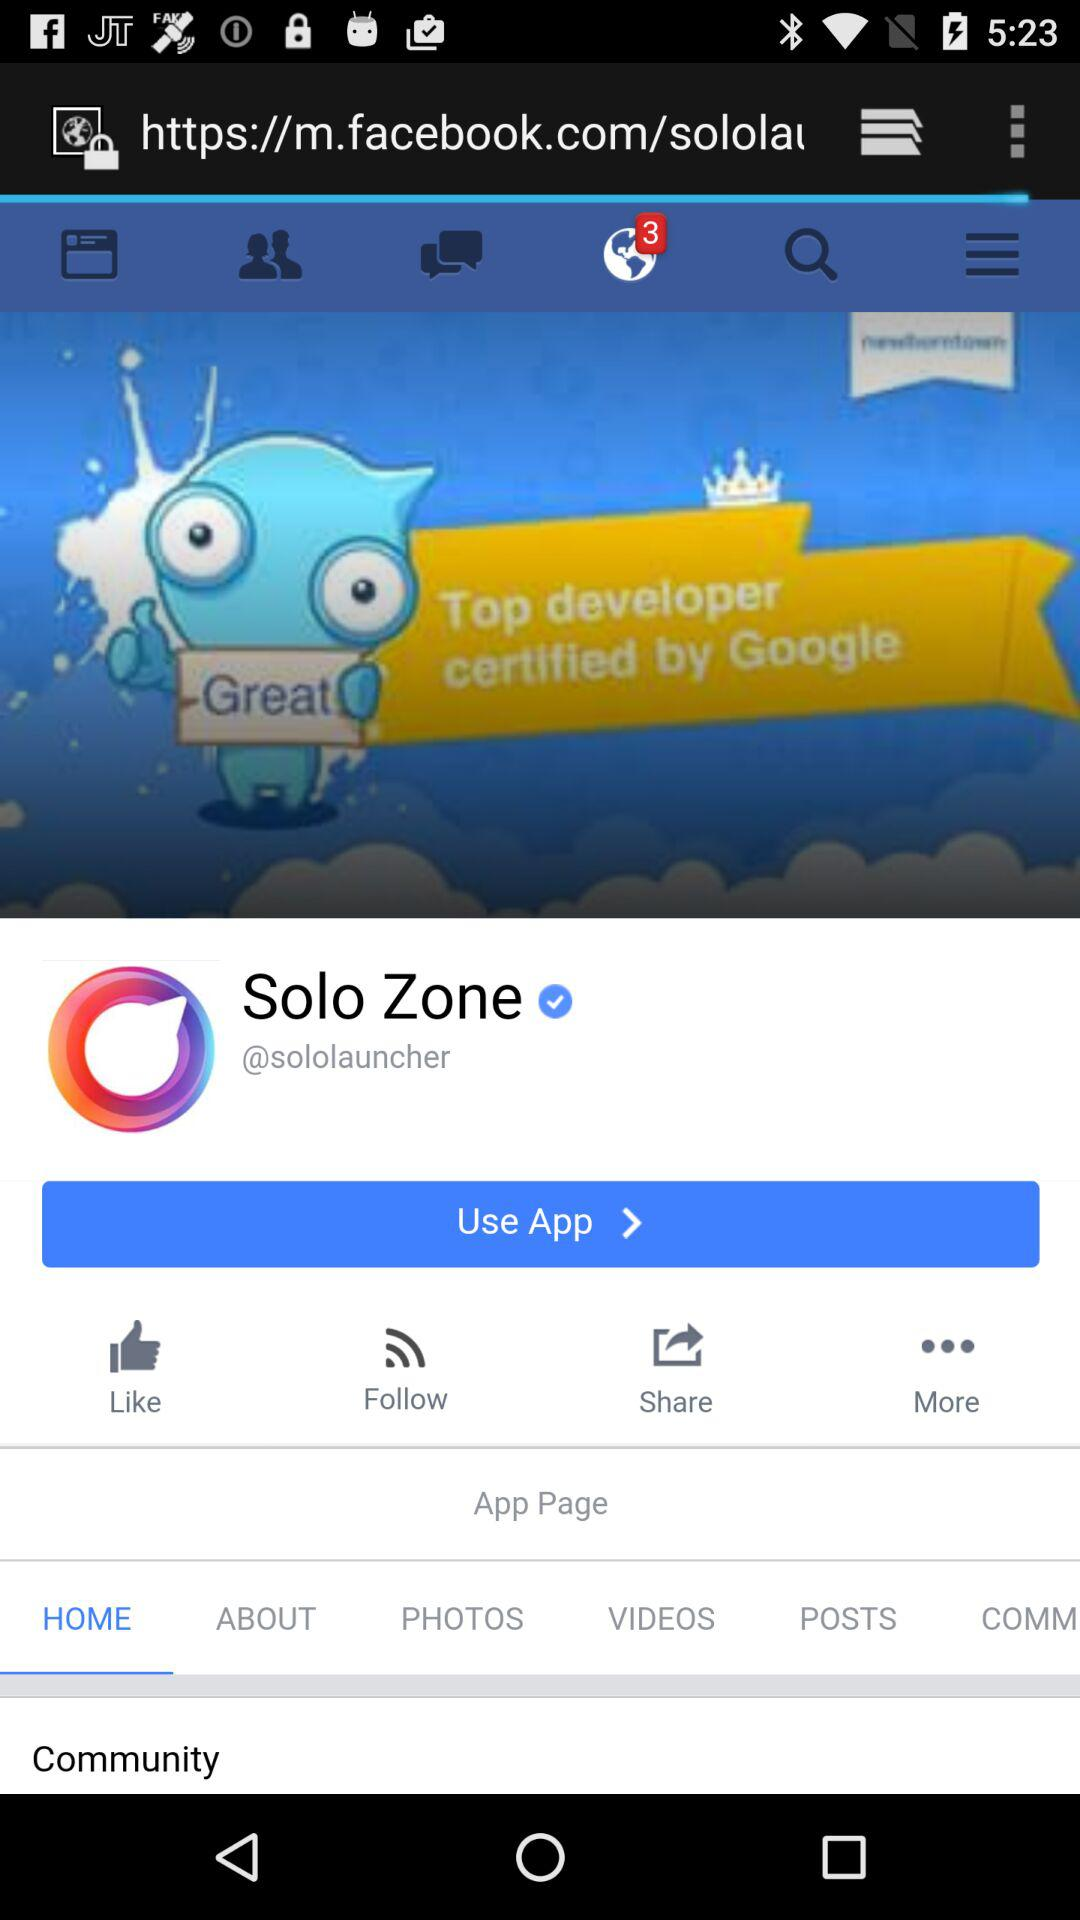What is the name of application?
Answer the question using a single word or phrase. The name of the application is Solo Zone 